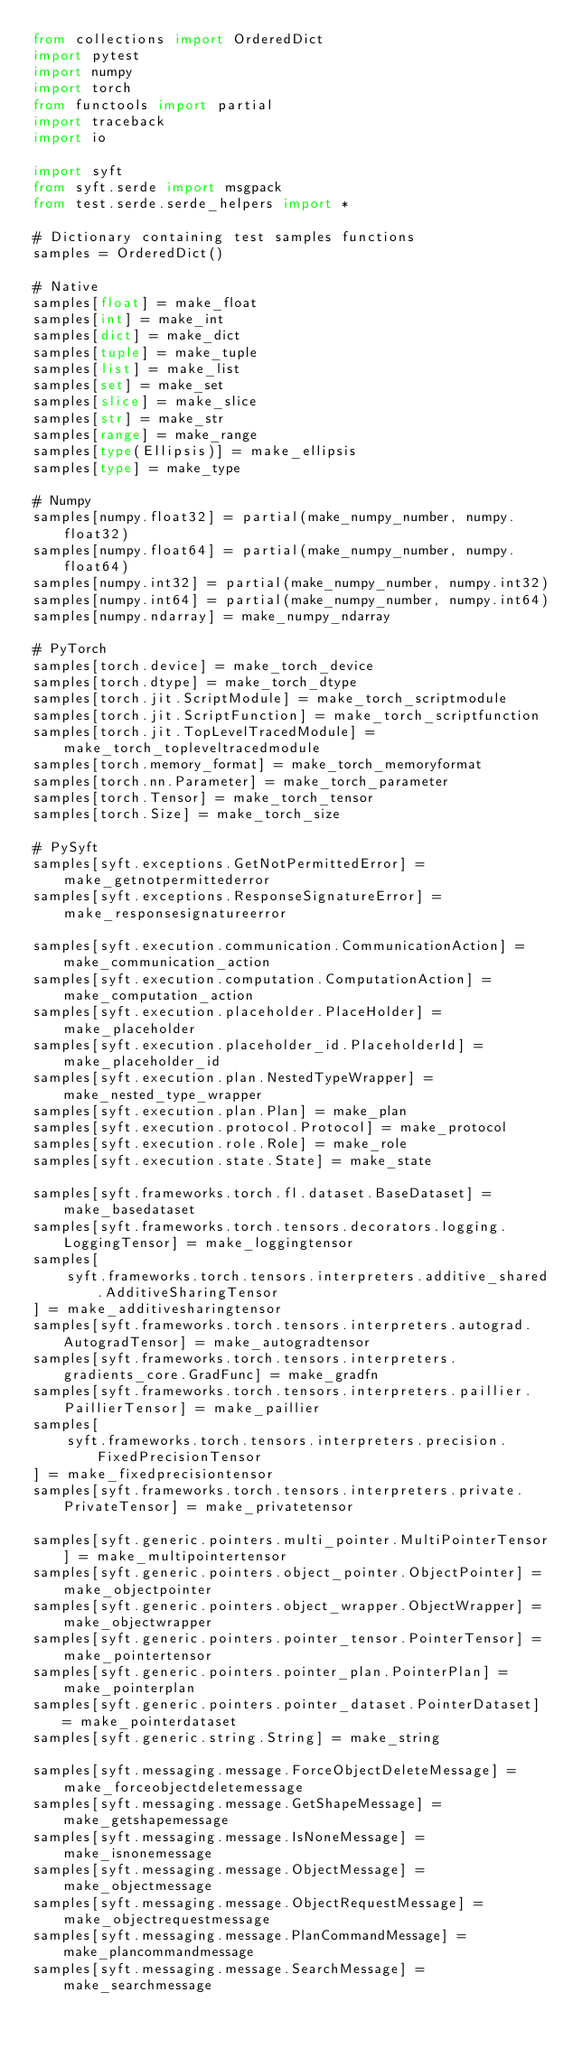<code> <loc_0><loc_0><loc_500><loc_500><_Python_>from collections import OrderedDict
import pytest
import numpy
import torch
from functools import partial
import traceback
import io

import syft
from syft.serde import msgpack
from test.serde.serde_helpers import *

# Dictionary containing test samples functions
samples = OrderedDict()

# Native
samples[float] = make_float
samples[int] = make_int
samples[dict] = make_dict
samples[tuple] = make_tuple
samples[list] = make_list
samples[set] = make_set
samples[slice] = make_slice
samples[str] = make_str
samples[range] = make_range
samples[type(Ellipsis)] = make_ellipsis
samples[type] = make_type

# Numpy
samples[numpy.float32] = partial(make_numpy_number, numpy.float32)
samples[numpy.float64] = partial(make_numpy_number, numpy.float64)
samples[numpy.int32] = partial(make_numpy_number, numpy.int32)
samples[numpy.int64] = partial(make_numpy_number, numpy.int64)
samples[numpy.ndarray] = make_numpy_ndarray

# PyTorch
samples[torch.device] = make_torch_device
samples[torch.dtype] = make_torch_dtype
samples[torch.jit.ScriptModule] = make_torch_scriptmodule
samples[torch.jit.ScriptFunction] = make_torch_scriptfunction
samples[torch.jit.TopLevelTracedModule] = make_torch_topleveltracedmodule
samples[torch.memory_format] = make_torch_memoryformat
samples[torch.nn.Parameter] = make_torch_parameter
samples[torch.Tensor] = make_torch_tensor
samples[torch.Size] = make_torch_size

# PySyft
samples[syft.exceptions.GetNotPermittedError] = make_getnotpermittederror
samples[syft.exceptions.ResponseSignatureError] = make_responsesignatureerror

samples[syft.execution.communication.CommunicationAction] = make_communication_action
samples[syft.execution.computation.ComputationAction] = make_computation_action
samples[syft.execution.placeholder.PlaceHolder] = make_placeholder
samples[syft.execution.placeholder_id.PlaceholderId] = make_placeholder_id
samples[syft.execution.plan.NestedTypeWrapper] = make_nested_type_wrapper
samples[syft.execution.plan.Plan] = make_plan
samples[syft.execution.protocol.Protocol] = make_protocol
samples[syft.execution.role.Role] = make_role
samples[syft.execution.state.State] = make_state

samples[syft.frameworks.torch.fl.dataset.BaseDataset] = make_basedataset
samples[syft.frameworks.torch.tensors.decorators.logging.LoggingTensor] = make_loggingtensor
samples[
    syft.frameworks.torch.tensors.interpreters.additive_shared.AdditiveSharingTensor
] = make_additivesharingtensor
samples[syft.frameworks.torch.tensors.interpreters.autograd.AutogradTensor] = make_autogradtensor
samples[syft.frameworks.torch.tensors.interpreters.gradients_core.GradFunc] = make_gradfn
samples[syft.frameworks.torch.tensors.interpreters.paillier.PaillierTensor] = make_paillier
samples[
    syft.frameworks.torch.tensors.interpreters.precision.FixedPrecisionTensor
] = make_fixedprecisiontensor
samples[syft.frameworks.torch.tensors.interpreters.private.PrivateTensor] = make_privatetensor

samples[syft.generic.pointers.multi_pointer.MultiPointerTensor] = make_multipointertensor
samples[syft.generic.pointers.object_pointer.ObjectPointer] = make_objectpointer
samples[syft.generic.pointers.object_wrapper.ObjectWrapper] = make_objectwrapper
samples[syft.generic.pointers.pointer_tensor.PointerTensor] = make_pointertensor
samples[syft.generic.pointers.pointer_plan.PointerPlan] = make_pointerplan
samples[syft.generic.pointers.pointer_dataset.PointerDataset] = make_pointerdataset
samples[syft.generic.string.String] = make_string

samples[syft.messaging.message.ForceObjectDeleteMessage] = make_forceobjectdeletemessage
samples[syft.messaging.message.GetShapeMessage] = make_getshapemessage
samples[syft.messaging.message.IsNoneMessage] = make_isnonemessage
samples[syft.messaging.message.ObjectMessage] = make_objectmessage
samples[syft.messaging.message.ObjectRequestMessage] = make_objectrequestmessage
samples[syft.messaging.message.PlanCommandMessage] = make_plancommandmessage
samples[syft.messaging.message.SearchMessage] = make_searchmessage</code> 